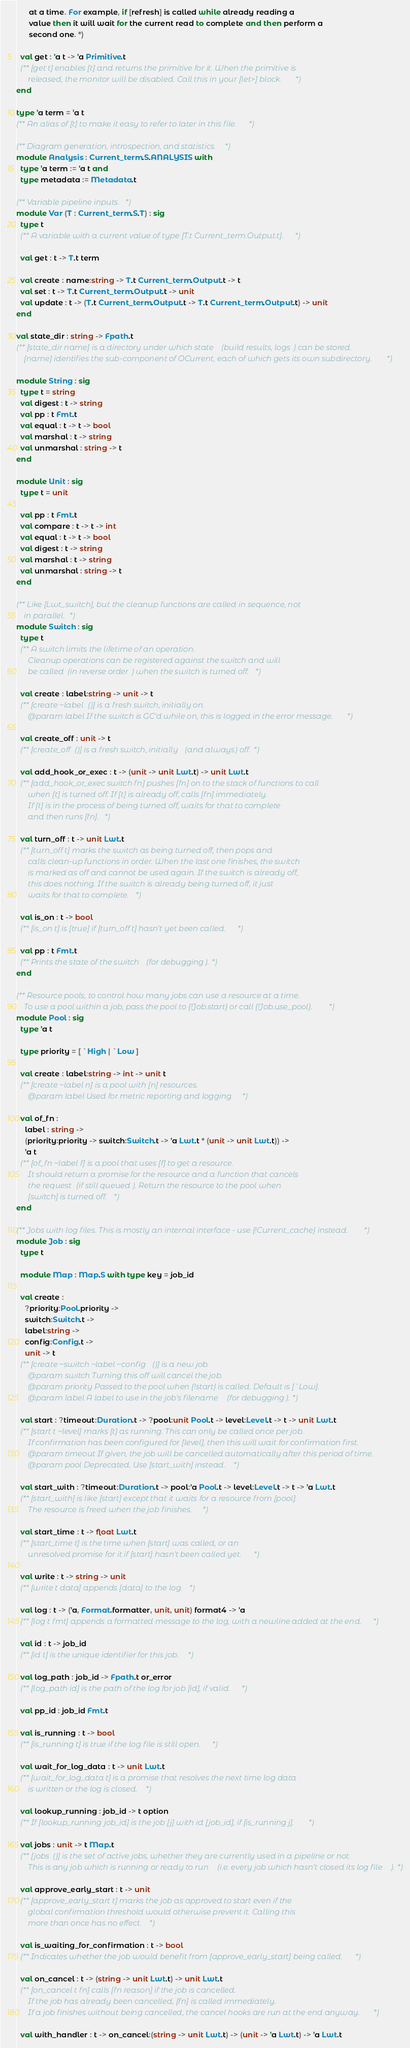Convert code to text. <code><loc_0><loc_0><loc_500><loc_500><_OCaml_>      at a time. For example, if [refresh] is called while already reading a
      value then it will wait for the current read to complete and then perform a
      second one. *)

  val get : 'a t -> 'a Primitive.t
  (** [get t] enables [t] and returns the primitive for it. When the primitive is
      released, the monitor will be disabled. Call this in your [let>] block. *)
end

type 'a term = 'a t
(** An alias of [t] to make it easy to refer to later in this file. *)

(** Diagram generation, introspection, and statistics. *)
module Analysis : Current_term.S.ANALYSIS with
  type 'a term := 'a t and
  type metadata := Metadata.t

(** Variable pipeline inputs. *)
module Var (T : Current_term.S.T) : sig
  type t
  (** A variable with a current value of type [T.t Current_term.Output.t]. *)

  val get : t -> T.t term

  val create : name:string -> T.t Current_term.Output.t -> t
  val set : t -> T.t Current_term.Output.t -> unit
  val update : t -> (T.t Current_term.Output.t -> T.t Current_term.Output.t) -> unit
end

val state_dir : string -> Fpath.t
(** [state_dir name] is a directory under which state (build results, logs) can be stored.
    [name] identifies the sub-component of OCurrent, each of which gets its own subdirectory. *)

module String : sig
  type t = string
  val digest : t -> string
  val pp : t Fmt.t
  val equal : t -> t -> bool
  val marshal : t -> string
  val unmarshal : string -> t
end

module Unit : sig
  type t = unit

  val pp : t Fmt.t
  val compare : t -> t -> int
  val equal : t -> t -> bool
  val digest : t -> string
  val marshal : t -> string
  val unmarshal : string -> t
end

(** Like [Lwt_switch], but the cleanup functions are called in sequence, not
    in parallel. *)
module Switch : sig
  type t
  (** A switch limits the lifetime of an operation.
      Cleanup operations can be registered against the switch and will
      be called (in reverse order) when the switch is turned off. *)

  val create : label:string -> unit -> t
  (** [create ~label ()] is a fresh switch, initially on.
      @param label If the switch is GC'd while on, this is logged in the error message. *)

  val create_off : unit -> t
  (** [create_off ()] is a fresh switch, initially (and always) off. *)

  val add_hook_or_exec : t -> (unit -> unit Lwt.t) -> unit Lwt.t
  (** [add_hook_or_exec switch fn] pushes [fn] on to the stack of functions to call
      when [t] is turned off. If [t] is already off, calls [fn] immediately.
      If [t] is in the process of being turned off, waits for that to complete
      and then runs [fn]. *)

  val turn_off : t -> unit Lwt.t
  (** [turn_off t] marks the switch as being turned off, then pops and
      calls clean-up functions in order. When the last one finishes, the switch
      is marked as off and cannot be used again. If the switch is already off,
      this does nothing. If the switch is already being turned off, it just
      waits for that to complete. *)

  val is_on : t -> bool
  (** [is_on t] is [true] if [turn_off t] hasn't yet been called. *)

  val pp : t Fmt.t
  (** Prints the state of the switch (for debugging). *)
end

(** Resource pools, to control how many jobs can use a resource at a time.
    To use a pool within a job, pass the pool to {!Job.start} or call {!Job.use_pool}. *)
module Pool : sig
  type 'a t

  type priority = [ `High | `Low ]

  val create : label:string -> int -> unit t
  (** [create ~label n] is a pool with [n] resources.
      @param label Used for metric reporting and logging. *)

  val of_fn :
    label : string ->
    (priority:priority -> switch:Switch.t -> 'a Lwt.t * (unit -> unit Lwt.t)) ->
    'a t
  (** [of_fn ~label f] is a pool that uses [f] to get a resource.
      It should return a promise for the resource and a function that cancels
      the request (if still queued). Return the resource to the pool when
      [switch] is turned off. *)
end

(** Jobs with log files. This is mostly an internal interface - use {!Current_cache} instead. *)
module Job : sig
  type t

  module Map : Map.S with type key = job_id

  val create :
    ?priority:Pool.priority ->
    switch:Switch.t ->
    label:string ->
    config:Config.t ->
    unit -> t
  (** [create ~switch ~label ~config ()] is a new job.
      @param switch Turning this off will cancel the job.
      @param priority Passed to the pool when {!start} is called. Default is [`Low].
      @param label A label to use in the job's filename (for debugging). *)

  val start : ?timeout:Duration.t -> ?pool:unit Pool.t -> level:Level.t -> t -> unit Lwt.t
  (** [start t ~level] marks [t] as running. This can only be called once per job.
      If confirmation has been configured for [level], then this will wait for confirmation first.
      @param timeout If given, the job will be cancelled automatically after this period of time.
      @param pool Deprecated. Use [start_with] instead. *)

  val start_with : ?timeout:Duration.t -> pool:'a Pool.t -> level:Level.t -> t -> 'a Lwt.t
  (** [start_with] is like [start] except that it waits for a resource from [pool].
      The resource is freed when the job finishes. *)

  val start_time : t -> float Lwt.t
  (** [start_time t] is the time when [start] was called, or an
      unresolved promise for it if [start] hasn't been called yet. *)

  val write : t -> string -> unit
  (** [write t data] appends [data] to the log. *)

  val log : t -> ('a, Format.formatter, unit, unit) format4 -> 'a
  (** [log t fmt] appends a formatted message to the log, with a newline added at the end. *)

  val id : t -> job_id
  (** [id t] is the unique identifier for this job. *)

  val log_path : job_id -> Fpath.t or_error
  (** [log_path id] is the path of the log for job [id], if valid. *)

  val pp_id : job_id Fmt.t

  val is_running : t -> bool
  (** [is_running t] is true if the log file is still open. *)

  val wait_for_log_data : t -> unit Lwt.t
  (** [wait_for_log_data t] is a promise that resolves the next time log data
      is written or the log is closed. *)

  val lookup_running : job_id -> t option
  (** If [lookup_running job_id] is the job [j] with id [job_id], if [is_running j]. *)

  val jobs : unit -> t Map.t
  (** [jobs ()] is the set of active jobs, whether they are currently used in a pipeline or not.
      This is any job which is running or ready to run (i.e. every job which hasn't closed its log file). *)

  val approve_early_start : t -> unit
  (** [approve_early_start t] marks the job as approved to start even if the
      global confirmation threshold would otherwise prevent it. Calling this
      more than once has no effect. *)

  val is_waiting_for_confirmation : t -> bool
  (** Indicates whether the job would benefit from [approve_early_start] being called. *)

  val on_cancel : t -> (string -> unit Lwt.t) -> unit Lwt.t
  (** [on_cancel t fn] calls [fn reason] if the job is cancelled.
      If the job has already been cancelled, [fn] is called immediately.
      If a job finishes without being cancelled, the cancel hooks are run at the end anyway. *)

  val with_handler : t -> on_cancel:(string -> unit Lwt.t) -> (unit -> 'a Lwt.t) -> 'a Lwt.t</code> 